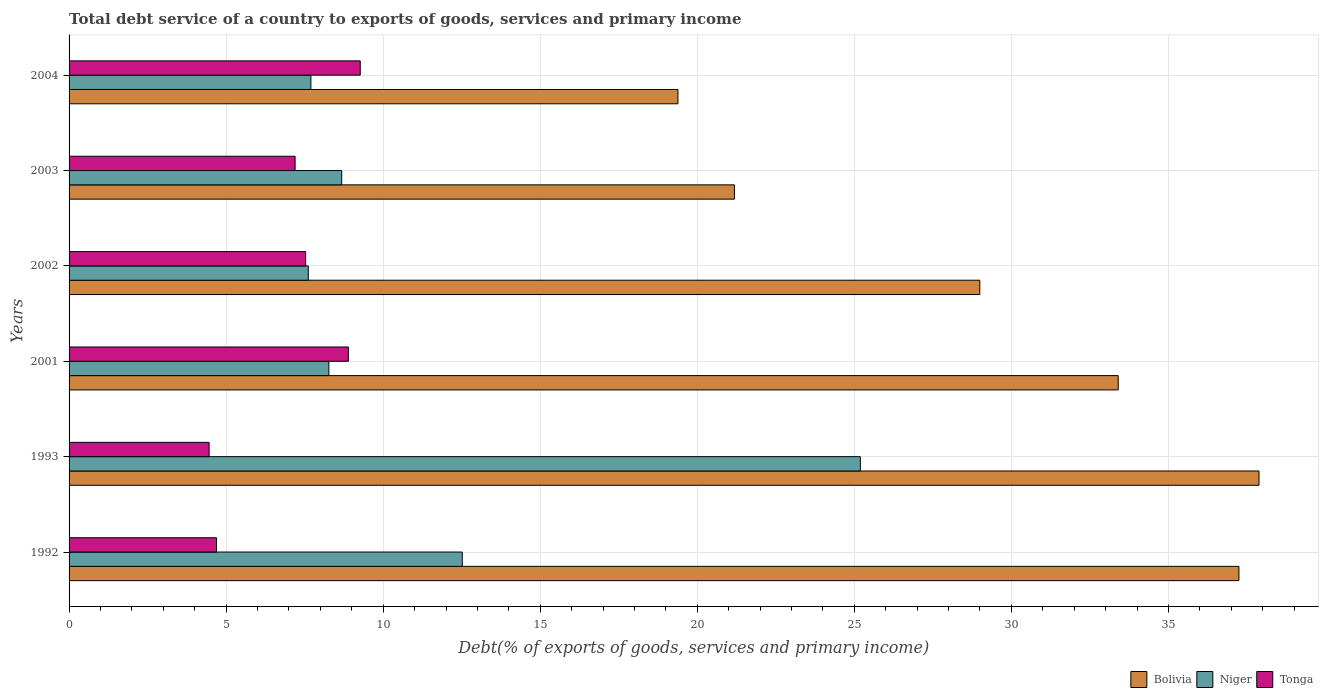Are the number of bars per tick equal to the number of legend labels?
Make the answer very short. Yes. Are the number of bars on each tick of the Y-axis equal?
Keep it short and to the point. Yes. How many bars are there on the 3rd tick from the bottom?
Offer a very short reply. 3. In how many cases, is the number of bars for a given year not equal to the number of legend labels?
Your answer should be very brief. 0. What is the total debt service in Tonga in 2003?
Ensure brevity in your answer.  7.2. Across all years, what is the maximum total debt service in Tonga?
Provide a succinct answer. 9.27. Across all years, what is the minimum total debt service in Tonga?
Give a very brief answer. 4.46. In which year was the total debt service in Tonga minimum?
Ensure brevity in your answer.  1993. What is the total total debt service in Tonga in the graph?
Make the answer very short. 42.04. What is the difference between the total debt service in Niger in 2002 and that in 2003?
Offer a very short reply. -1.06. What is the difference between the total debt service in Niger in 1993 and the total debt service in Tonga in 2003?
Your answer should be compact. 17.99. What is the average total debt service in Tonga per year?
Make the answer very short. 7.01. In the year 1992, what is the difference between the total debt service in Bolivia and total debt service in Niger?
Ensure brevity in your answer.  24.73. What is the ratio of the total debt service in Niger in 1993 to that in 2002?
Your response must be concise. 3.31. Is the total debt service in Niger in 1993 less than that in 2003?
Give a very brief answer. No. What is the difference between the highest and the second highest total debt service in Niger?
Keep it short and to the point. 12.67. What is the difference between the highest and the lowest total debt service in Tonga?
Ensure brevity in your answer.  4.81. In how many years, is the total debt service in Tonga greater than the average total debt service in Tonga taken over all years?
Provide a succinct answer. 4. Is the sum of the total debt service in Bolivia in 2001 and 2004 greater than the maximum total debt service in Tonga across all years?
Offer a terse response. Yes. What does the 2nd bar from the top in 2004 represents?
Offer a terse response. Niger. What does the 2nd bar from the bottom in 2001 represents?
Ensure brevity in your answer.  Niger. Is it the case that in every year, the sum of the total debt service in Tonga and total debt service in Bolivia is greater than the total debt service in Niger?
Your answer should be compact. Yes. Are all the bars in the graph horizontal?
Your answer should be compact. Yes. Does the graph contain any zero values?
Provide a succinct answer. No. How many legend labels are there?
Keep it short and to the point. 3. How are the legend labels stacked?
Provide a succinct answer. Horizontal. What is the title of the graph?
Your answer should be compact. Total debt service of a country to exports of goods, services and primary income. Does "Cote d'Ivoire" appear as one of the legend labels in the graph?
Ensure brevity in your answer.  No. What is the label or title of the X-axis?
Make the answer very short. Debt(% of exports of goods, services and primary income). What is the label or title of the Y-axis?
Provide a succinct answer. Years. What is the Debt(% of exports of goods, services and primary income) in Bolivia in 1992?
Make the answer very short. 37.24. What is the Debt(% of exports of goods, services and primary income) in Niger in 1992?
Your response must be concise. 12.52. What is the Debt(% of exports of goods, services and primary income) of Tonga in 1992?
Keep it short and to the point. 4.69. What is the Debt(% of exports of goods, services and primary income) in Bolivia in 1993?
Ensure brevity in your answer.  37.88. What is the Debt(% of exports of goods, services and primary income) in Niger in 1993?
Your answer should be compact. 25.19. What is the Debt(% of exports of goods, services and primary income) of Tonga in 1993?
Provide a short and direct response. 4.46. What is the Debt(% of exports of goods, services and primary income) in Bolivia in 2001?
Your response must be concise. 33.4. What is the Debt(% of exports of goods, services and primary income) of Niger in 2001?
Ensure brevity in your answer.  8.27. What is the Debt(% of exports of goods, services and primary income) in Tonga in 2001?
Your answer should be compact. 8.89. What is the Debt(% of exports of goods, services and primary income) in Bolivia in 2002?
Make the answer very short. 28.99. What is the Debt(% of exports of goods, services and primary income) of Niger in 2002?
Ensure brevity in your answer.  7.62. What is the Debt(% of exports of goods, services and primary income) of Tonga in 2002?
Offer a very short reply. 7.53. What is the Debt(% of exports of goods, services and primary income) in Bolivia in 2003?
Provide a succinct answer. 21.18. What is the Debt(% of exports of goods, services and primary income) in Niger in 2003?
Provide a short and direct response. 8.68. What is the Debt(% of exports of goods, services and primary income) in Tonga in 2003?
Keep it short and to the point. 7.2. What is the Debt(% of exports of goods, services and primary income) of Bolivia in 2004?
Provide a short and direct response. 19.38. What is the Debt(% of exports of goods, services and primary income) of Niger in 2004?
Keep it short and to the point. 7.7. What is the Debt(% of exports of goods, services and primary income) in Tonga in 2004?
Ensure brevity in your answer.  9.27. Across all years, what is the maximum Debt(% of exports of goods, services and primary income) of Bolivia?
Give a very brief answer. 37.88. Across all years, what is the maximum Debt(% of exports of goods, services and primary income) of Niger?
Give a very brief answer. 25.19. Across all years, what is the maximum Debt(% of exports of goods, services and primary income) of Tonga?
Provide a short and direct response. 9.27. Across all years, what is the minimum Debt(% of exports of goods, services and primary income) of Bolivia?
Offer a terse response. 19.38. Across all years, what is the minimum Debt(% of exports of goods, services and primary income) of Niger?
Offer a very short reply. 7.62. Across all years, what is the minimum Debt(% of exports of goods, services and primary income) in Tonga?
Offer a terse response. 4.46. What is the total Debt(% of exports of goods, services and primary income) in Bolivia in the graph?
Offer a terse response. 178.09. What is the total Debt(% of exports of goods, services and primary income) of Niger in the graph?
Ensure brevity in your answer.  69.97. What is the total Debt(% of exports of goods, services and primary income) of Tonga in the graph?
Offer a terse response. 42.04. What is the difference between the Debt(% of exports of goods, services and primary income) in Bolivia in 1992 and that in 1993?
Your response must be concise. -0.64. What is the difference between the Debt(% of exports of goods, services and primary income) of Niger in 1992 and that in 1993?
Ensure brevity in your answer.  -12.67. What is the difference between the Debt(% of exports of goods, services and primary income) of Tonga in 1992 and that in 1993?
Make the answer very short. 0.24. What is the difference between the Debt(% of exports of goods, services and primary income) of Bolivia in 1992 and that in 2001?
Give a very brief answer. 3.84. What is the difference between the Debt(% of exports of goods, services and primary income) of Niger in 1992 and that in 2001?
Your answer should be compact. 4.25. What is the difference between the Debt(% of exports of goods, services and primary income) in Tonga in 1992 and that in 2001?
Provide a short and direct response. -4.2. What is the difference between the Debt(% of exports of goods, services and primary income) of Bolivia in 1992 and that in 2002?
Give a very brief answer. 8.25. What is the difference between the Debt(% of exports of goods, services and primary income) of Niger in 1992 and that in 2002?
Your answer should be very brief. 4.9. What is the difference between the Debt(% of exports of goods, services and primary income) in Tonga in 1992 and that in 2002?
Keep it short and to the point. -2.84. What is the difference between the Debt(% of exports of goods, services and primary income) of Bolivia in 1992 and that in 2003?
Make the answer very short. 16.06. What is the difference between the Debt(% of exports of goods, services and primary income) in Niger in 1992 and that in 2003?
Offer a very short reply. 3.84. What is the difference between the Debt(% of exports of goods, services and primary income) of Tonga in 1992 and that in 2003?
Your answer should be very brief. -2.5. What is the difference between the Debt(% of exports of goods, services and primary income) of Bolivia in 1992 and that in 2004?
Give a very brief answer. 17.86. What is the difference between the Debt(% of exports of goods, services and primary income) in Niger in 1992 and that in 2004?
Offer a terse response. 4.82. What is the difference between the Debt(% of exports of goods, services and primary income) in Tonga in 1992 and that in 2004?
Offer a very short reply. -4.58. What is the difference between the Debt(% of exports of goods, services and primary income) in Bolivia in 1993 and that in 2001?
Offer a terse response. 4.48. What is the difference between the Debt(% of exports of goods, services and primary income) in Niger in 1993 and that in 2001?
Offer a very short reply. 16.92. What is the difference between the Debt(% of exports of goods, services and primary income) in Tonga in 1993 and that in 2001?
Provide a succinct answer. -4.43. What is the difference between the Debt(% of exports of goods, services and primary income) in Bolivia in 1993 and that in 2002?
Give a very brief answer. 8.89. What is the difference between the Debt(% of exports of goods, services and primary income) in Niger in 1993 and that in 2002?
Your response must be concise. 17.58. What is the difference between the Debt(% of exports of goods, services and primary income) in Tonga in 1993 and that in 2002?
Keep it short and to the point. -3.07. What is the difference between the Debt(% of exports of goods, services and primary income) of Bolivia in 1993 and that in 2003?
Give a very brief answer. 16.7. What is the difference between the Debt(% of exports of goods, services and primary income) of Niger in 1993 and that in 2003?
Offer a very short reply. 16.51. What is the difference between the Debt(% of exports of goods, services and primary income) of Tonga in 1993 and that in 2003?
Ensure brevity in your answer.  -2.74. What is the difference between the Debt(% of exports of goods, services and primary income) in Bolivia in 1993 and that in 2004?
Give a very brief answer. 18.5. What is the difference between the Debt(% of exports of goods, services and primary income) in Niger in 1993 and that in 2004?
Your answer should be very brief. 17.49. What is the difference between the Debt(% of exports of goods, services and primary income) of Tonga in 1993 and that in 2004?
Provide a succinct answer. -4.81. What is the difference between the Debt(% of exports of goods, services and primary income) in Bolivia in 2001 and that in 2002?
Your response must be concise. 4.41. What is the difference between the Debt(% of exports of goods, services and primary income) of Niger in 2001 and that in 2002?
Provide a succinct answer. 0.66. What is the difference between the Debt(% of exports of goods, services and primary income) of Tonga in 2001 and that in 2002?
Your response must be concise. 1.36. What is the difference between the Debt(% of exports of goods, services and primary income) of Bolivia in 2001 and that in 2003?
Ensure brevity in your answer.  12.22. What is the difference between the Debt(% of exports of goods, services and primary income) in Niger in 2001 and that in 2003?
Your answer should be very brief. -0.41. What is the difference between the Debt(% of exports of goods, services and primary income) in Tonga in 2001 and that in 2003?
Provide a succinct answer. 1.7. What is the difference between the Debt(% of exports of goods, services and primary income) of Bolivia in 2001 and that in 2004?
Provide a short and direct response. 14.02. What is the difference between the Debt(% of exports of goods, services and primary income) in Niger in 2001 and that in 2004?
Give a very brief answer. 0.57. What is the difference between the Debt(% of exports of goods, services and primary income) of Tonga in 2001 and that in 2004?
Your answer should be very brief. -0.38. What is the difference between the Debt(% of exports of goods, services and primary income) in Bolivia in 2002 and that in 2003?
Offer a very short reply. 7.81. What is the difference between the Debt(% of exports of goods, services and primary income) in Niger in 2002 and that in 2003?
Give a very brief answer. -1.06. What is the difference between the Debt(% of exports of goods, services and primary income) of Tonga in 2002 and that in 2003?
Your response must be concise. 0.33. What is the difference between the Debt(% of exports of goods, services and primary income) of Bolivia in 2002 and that in 2004?
Offer a terse response. 9.61. What is the difference between the Debt(% of exports of goods, services and primary income) of Niger in 2002 and that in 2004?
Keep it short and to the point. -0.08. What is the difference between the Debt(% of exports of goods, services and primary income) of Tonga in 2002 and that in 2004?
Your answer should be compact. -1.74. What is the difference between the Debt(% of exports of goods, services and primary income) of Bolivia in 2003 and that in 2004?
Give a very brief answer. 1.8. What is the difference between the Debt(% of exports of goods, services and primary income) in Niger in 2003 and that in 2004?
Provide a short and direct response. 0.98. What is the difference between the Debt(% of exports of goods, services and primary income) in Tonga in 2003 and that in 2004?
Provide a succinct answer. -2.07. What is the difference between the Debt(% of exports of goods, services and primary income) in Bolivia in 1992 and the Debt(% of exports of goods, services and primary income) in Niger in 1993?
Provide a succinct answer. 12.05. What is the difference between the Debt(% of exports of goods, services and primary income) of Bolivia in 1992 and the Debt(% of exports of goods, services and primary income) of Tonga in 1993?
Your response must be concise. 32.79. What is the difference between the Debt(% of exports of goods, services and primary income) in Niger in 1992 and the Debt(% of exports of goods, services and primary income) in Tonga in 1993?
Offer a very short reply. 8.06. What is the difference between the Debt(% of exports of goods, services and primary income) of Bolivia in 1992 and the Debt(% of exports of goods, services and primary income) of Niger in 2001?
Keep it short and to the point. 28.97. What is the difference between the Debt(% of exports of goods, services and primary income) of Bolivia in 1992 and the Debt(% of exports of goods, services and primary income) of Tonga in 2001?
Your answer should be very brief. 28.35. What is the difference between the Debt(% of exports of goods, services and primary income) in Niger in 1992 and the Debt(% of exports of goods, services and primary income) in Tonga in 2001?
Provide a short and direct response. 3.63. What is the difference between the Debt(% of exports of goods, services and primary income) of Bolivia in 1992 and the Debt(% of exports of goods, services and primary income) of Niger in 2002?
Offer a terse response. 29.63. What is the difference between the Debt(% of exports of goods, services and primary income) of Bolivia in 1992 and the Debt(% of exports of goods, services and primary income) of Tonga in 2002?
Your response must be concise. 29.71. What is the difference between the Debt(% of exports of goods, services and primary income) in Niger in 1992 and the Debt(% of exports of goods, services and primary income) in Tonga in 2002?
Offer a very short reply. 4.99. What is the difference between the Debt(% of exports of goods, services and primary income) in Bolivia in 1992 and the Debt(% of exports of goods, services and primary income) in Niger in 2003?
Provide a short and direct response. 28.57. What is the difference between the Debt(% of exports of goods, services and primary income) in Bolivia in 1992 and the Debt(% of exports of goods, services and primary income) in Tonga in 2003?
Keep it short and to the point. 30.05. What is the difference between the Debt(% of exports of goods, services and primary income) of Niger in 1992 and the Debt(% of exports of goods, services and primary income) of Tonga in 2003?
Make the answer very short. 5.32. What is the difference between the Debt(% of exports of goods, services and primary income) of Bolivia in 1992 and the Debt(% of exports of goods, services and primary income) of Niger in 2004?
Ensure brevity in your answer.  29.55. What is the difference between the Debt(% of exports of goods, services and primary income) in Bolivia in 1992 and the Debt(% of exports of goods, services and primary income) in Tonga in 2004?
Offer a terse response. 27.97. What is the difference between the Debt(% of exports of goods, services and primary income) of Niger in 1992 and the Debt(% of exports of goods, services and primary income) of Tonga in 2004?
Offer a very short reply. 3.25. What is the difference between the Debt(% of exports of goods, services and primary income) in Bolivia in 1993 and the Debt(% of exports of goods, services and primary income) in Niger in 2001?
Offer a terse response. 29.61. What is the difference between the Debt(% of exports of goods, services and primary income) of Bolivia in 1993 and the Debt(% of exports of goods, services and primary income) of Tonga in 2001?
Your answer should be very brief. 28.99. What is the difference between the Debt(% of exports of goods, services and primary income) of Niger in 1993 and the Debt(% of exports of goods, services and primary income) of Tonga in 2001?
Provide a short and direct response. 16.3. What is the difference between the Debt(% of exports of goods, services and primary income) of Bolivia in 1993 and the Debt(% of exports of goods, services and primary income) of Niger in 2002?
Make the answer very short. 30.27. What is the difference between the Debt(% of exports of goods, services and primary income) in Bolivia in 1993 and the Debt(% of exports of goods, services and primary income) in Tonga in 2002?
Ensure brevity in your answer.  30.35. What is the difference between the Debt(% of exports of goods, services and primary income) of Niger in 1993 and the Debt(% of exports of goods, services and primary income) of Tonga in 2002?
Make the answer very short. 17.66. What is the difference between the Debt(% of exports of goods, services and primary income) of Bolivia in 1993 and the Debt(% of exports of goods, services and primary income) of Niger in 2003?
Make the answer very short. 29.2. What is the difference between the Debt(% of exports of goods, services and primary income) in Bolivia in 1993 and the Debt(% of exports of goods, services and primary income) in Tonga in 2003?
Make the answer very short. 30.69. What is the difference between the Debt(% of exports of goods, services and primary income) in Niger in 1993 and the Debt(% of exports of goods, services and primary income) in Tonga in 2003?
Make the answer very short. 17.99. What is the difference between the Debt(% of exports of goods, services and primary income) of Bolivia in 1993 and the Debt(% of exports of goods, services and primary income) of Niger in 2004?
Provide a succinct answer. 30.18. What is the difference between the Debt(% of exports of goods, services and primary income) of Bolivia in 1993 and the Debt(% of exports of goods, services and primary income) of Tonga in 2004?
Provide a succinct answer. 28.61. What is the difference between the Debt(% of exports of goods, services and primary income) in Niger in 1993 and the Debt(% of exports of goods, services and primary income) in Tonga in 2004?
Give a very brief answer. 15.92. What is the difference between the Debt(% of exports of goods, services and primary income) of Bolivia in 2001 and the Debt(% of exports of goods, services and primary income) of Niger in 2002?
Give a very brief answer. 25.79. What is the difference between the Debt(% of exports of goods, services and primary income) of Bolivia in 2001 and the Debt(% of exports of goods, services and primary income) of Tonga in 2002?
Your answer should be compact. 25.87. What is the difference between the Debt(% of exports of goods, services and primary income) in Niger in 2001 and the Debt(% of exports of goods, services and primary income) in Tonga in 2002?
Offer a very short reply. 0.74. What is the difference between the Debt(% of exports of goods, services and primary income) in Bolivia in 2001 and the Debt(% of exports of goods, services and primary income) in Niger in 2003?
Give a very brief answer. 24.72. What is the difference between the Debt(% of exports of goods, services and primary income) in Bolivia in 2001 and the Debt(% of exports of goods, services and primary income) in Tonga in 2003?
Offer a terse response. 26.21. What is the difference between the Debt(% of exports of goods, services and primary income) of Niger in 2001 and the Debt(% of exports of goods, services and primary income) of Tonga in 2003?
Your answer should be very brief. 1.07. What is the difference between the Debt(% of exports of goods, services and primary income) in Bolivia in 2001 and the Debt(% of exports of goods, services and primary income) in Niger in 2004?
Ensure brevity in your answer.  25.7. What is the difference between the Debt(% of exports of goods, services and primary income) of Bolivia in 2001 and the Debt(% of exports of goods, services and primary income) of Tonga in 2004?
Your answer should be compact. 24.13. What is the difference between the Debt(% of exports of goods, services and primary income) of Niger in 2001 and the Debt(% of exports of goods, services and primary income) of Tonga in 2004?
Your answer should be very brief. -1. What is the difference between the Debt(% of exports of goods, services and primary income) of Bolivia in 2002 and the Debt(% of exports of goods, services and primary income) of Niger in 2003?
Ensure brevity in your answer.  20.32. What is the difference between the Debt(% of exports of goods, services and primary income) in Bolivia in 2002 and the Debt(% of exports of goods, services and primary income) in Tonga in 2003?
Make the answer very short. 21.8. What is the difference between the Debt(% of exports of goods, services and primary income) of Niger in 2002 and the Debt(% of exports of goods, services and primary income) of Tonga in 2003?
Keep it short and to the point. 0.42. What is the difference between the Debt(% of exports of goods, services and primary income) in Bolivia in 2002 and the Debt(% of exports of goods, services and primary income) in Niger in 2004?
Your answer should be compact. 21.3. What is the difference between the Debt(% of exports of goods, services and primary income) in Bolivia in 2002 and the Debt(% of exports of goods, services and primary income) in Tonga in 2004?
Provide a short and direct response. 19.72. What is the difference between the Debt(% of exports of goods, services and primary income) of Niger in 2002 and the Debt(% of exports of goods, services and primary income) of Tonga in 2004?
Ensure brevity in your answer.  -1.65. What is the difference between the Debt(% of exports of goods, services and primary income) in Bolivia in 2003 and the Debt(% of exports of goods, services and primary income) in Niger in 2004?
Your answer should be very brief. 13.48. What is the difference between the Debt(% of exports of goods, services and primary income) of Bolivia in 2003 and the Debt(% of exports of goods, services and primary income) of Tonga in 2004?
Offer a terse response. 11.91. What is the difference between the Debt(% of exports of goods, services and primary income) in Niger in 2003 and the Debt(% of exports of goods, services and primary income) in Tonga in 2004?
Offer a terse response. -0.59. What is the average Debt(% of exports of goods, services and primary income) of Bolivia per year?
Your response must be concise. 29.68. What is the average Debt(% of exports of goods, services and primary income) in Niger per year?
Provide a short and direct response. 11.66. What is the average Debt(% of exports of goods, services and primary income) of Tonga per year?
Provide a short and direct response. 7.01. In the year 1992, what is the difference between the Debt(% of exports of goods, services and primary income) in Bolivia and Debt(% of exports of goods, services and primary income) in Niger?
Make the answer very short. 24.73. In the year 1992, what is the difference between the Debt(% of exports of goods, services and primary income) in Bolivia and Debt(% of exports of goods, services and primary income) in Tonga?
Your answer should be very brief. 32.55. In the year 1992, what is the difference between the Debt(% of exports of goods, services and primary income) in Niger and Debt(% of exports of goods, services and primary income) in Tonga?
Offer a terse response. 7.83. In the year 1993, what is the difference between the Debt(% of exports of goods, services and primary income) in Bolivia and Debt(% of exports of goods, services and primary income) in Niger?
Provide a short and direct response. 12.69. In the year 1993, what is the difference between the Debt(% of exports of goods, services and primary income) in Bolivia and Debt(% of exports of goods, services and primary income) in Tonga?
Your answer should be very brief. 33.42. In the year 1993, what is the difference between the Debt(% of exports of goods, services and primary income) of Niger and Debt(% of exports of goods, services and primary income) of Tonga?
Keep it short and to the point. 20.73. In the year 2001, what is the difference between the Debt(% of exports of goods, services and primary income) of Bolivia and Debt(% of exports of goods, services and primary income) of Niger?
Your response must be concise. 25.13. In the year 2001, what is the difference between the Debt(% of exports of goods, services and primary income) in Bolivia and Debt(% of exports of goods, services and primary income) in Tonga?
Ensure brevity in your answer.  24.51. In the year 2001, what is the difference between the Debt(% of exports of goods, services and primary income) in Niger and Debt(% of exports of goods, services and primary income) in Tonga?
Your answer should be very brief. -0.62. In the year 2002, what is the difference between the Debt(% of exports of goods, services and primary income) of Bolivia and Debt(% of exports of goods, services and primary income) of Niger?
Your answer should be very brief. 21.38. In the year 2002, what is the difference between the Debt(% of exports of goods, services and primary income) of Bolivia and Debt(% of exports of goods, services and primary income) of Tonga?
Provide a short and direct response. 21.46. In the year 2002, what is the difference between the Debt(% of exports of goods, services and primary income) in Niger and Debt(% of exports of goods, services and primary income) in Tonga?
Your answer should be very brief. 0.08. In the year 2003, what is the difference between the Debt(% of exports of goods, services and primary income) of Bolivia and Debt(% of exports of goods, services and primary income) of Niger?
Your response must be concise. 12.5. In the year 2003, what is the difference between the Debt(% of exports of goods, services and primary income) in Bolivia and Debt(% of exports of goods, services and primary income) in Tonga?
Make the answer very short. 13.99. In the year 2003, what is the difference between the Debt(% of exports of goods, services and primary income) of Niger and Debt(% of exports of goods, services and primary income) of Tonga?
Provide a short and direct response. 1.48. In the year 2004, what is the difference between the Debt(% of exports of goods, services and primary income) in Bolivia and Debt(% of exports of goods, services and primary income) in Niger?
Keep it short and to the point. 11.69. In the year 2004, what is the difference between the Debt(% of exports of goods, services and primary income) in Bolivia and Debt(% of exports of goods, services and primary income) in Tonga?
Keep it short and to the point. 10.11. In the year 2004, what is the difference between the Debt(% of exports of goods, services and primary income) in Niger and Debt(% of exports of goods, services and primary income) in Tonga?
Your response must be concise. -1.57. What is the ratio of the Debt(% of exports of goods, services and primary income) in Bolivia in 1992 to that in 1993?
Your response must be concise. 0.98. What is the ratio of the Debt(% of exports of goods, services and primary income) in Niger in 1992 to that in 1993?
Make the answer very short. 0.5. What is the ratio of the Debt(% of exports of goods, services and primary income) in Tonga in 1992 to that in 1993?
Provide a short and direct response. 1.05. What is the ratio of the Debt(% of exports of goods, services and primary income) in Bolivia in 1992 to that in 2001?
Give a very brief answer. 1.12. What is the ratio of the Debt(% of exports of goods, services and primary income) of Niger in 1992 to that in 2001?
Your answer should be compact. 1.51. What is the ratio of the Debt(% of exports of goods, services and primary income) of Tonga in 1992 to that in 2001?
Provide a succinct answer. 0.53. What is the ratio of the Debt(% of exports of goods, services and primary income) of Bolivia in 1992 to that in 2002?
Give a very brief answer. 1.28. What is the ratio of the Debt(% of exports of goods, services and primary income) of Niger in 1992 to that in 2002?
Keep it short and to the point. 1.64. What is the ratio of the Debt(% of exports of goods, services and primary income) of Tonga in 1992 to that in 2002?
Offer a terse response. 0.62. What is the ratio of the Debt(% of exports of goods, services and primary income) in Bolivia in 1992 to that in 2003?
Provide a succinct answer. 1.76. What is the ratio of the Debt(% of exports of goods, services and primary income) in Niger in 1992 to that in 2003?
Ensure brevity in your answer.  1.44. What is the ratio of the Debt(% of exports of goods, services and primary income) in Tonga in 1992 to that in 2003?
Keep it short and to the point. 0.65. What is the ratio of the Debt(% of exports of goods, services and primary income) in Bolivia in 1992 to that in 2004?
Offer a very short reply. 1.92. What is the ratio of the Debt(% of exports of goods, services and primary income) in Niger in 1992 to that in 2004?
Give a very brief answer. 1.63. What is the ratio of the Debt(% of exports of goods, services and primary income) in Tonga in 1992 to that in 2004?
Give a very brief answer. 0.51. What is the ratio of the Debt(% of exports of goods, services and primary income) in Bolivia in 1993 to that in 2001?
Your response must be concise. 1.13. What is the ratio of the Debt(% of exports of goods, services and primary income) in Niger in 1993 to that in 2001?
Ensure brevity in your answer.  3.05. What is the ratio of the Debt(% of exports of goods, services and primary income) in Tonga in 1993 to that in 2001?
Offer a very short reply. 0.5. What is the ratio of the Debt(% of exports of goods, services and primary income) of Bolivia in 1993 to that in 2002?
Your answer should be compact. 1.31. What is the ratio of the Debt(% of exports of goods, services and primary income) in Niger in 1993 to that in 2002?
Make the answer very short. 3.31. What is the ratio of the Debt(% of exports of goods, services and primary income) of Tonga in 1993 to that in 2002?
Offer a very short reply. 0.59. What is the ratio of the Debt(% of exports of goods, services and primary income) of Bolivia in 1993 to that in 2003?
Give a very brief answer. 1.79. What is the ratio of the Debt(% of exports of goods, services and primary income) of Niger in 1993 to that in 2003?
Make the answer very short. 2.9. What is the ratio of the Debt(% of exports of goods, services and primary income) of Tonga in 1993 to that in 2003?
Offer a terse response. 0.62. What is the ratio of the Debt(% of exports of goods, services and primary income) of Bolivia in 1993 to that in 2004?
Make the answer very short. 1.95. What is the ratio of the Debt(% of exports of goods, services and primary income) in Niger in 1993 to that in 2004?
Your response must be concise. 3.27. What is the ratio of the Debt(% of exports of goods, services and primary income) of Tonga in 1993 to that in 2004?
Offer a terse response. 0.48. What is the ratio of the Debt(% of exports of goods, services and primary income) of Bolivia in 2001 to that in 2002?
Your answer should be compact. 1.15. What is the ratio of the Debt(% of exports of goods, services and primary income) in Niger in 2001 to that in 2002?
Make the answer very short. 1.09. What is the ratio of the Debt(% of exports of goods, services and primary income) of Tonga in 2001 to that in 2002?
Give a very brief answer. 1.18. What is the ratio of the Debt(% of exports of goods, services and primary income) in Bolivia in 2001 to that in 2003?
Your answer should be compact. 1.58. What is the ratio of the Debt(% of exports of goods, services and primary income) in Niger in 2001 to that in 2003?
Offer a terse response. 0.95. What is the ratio of the Debt(% of exports of goods, services and primary income) in Tonga in 2001 to that in 2003?
Give a very brief answer. 1.24. What is the ratio of the Debt(% of exports of goods, services and primary income) in Bolivia in 2001 to that in 2004?
Give a very brief answer. 1.72. What is the ratio of the Debt(% of exports of goods, services and primary income) in Niger in 2001 to that in 2004?
Your answer should be compact. 1.07. What is the ratio of the Debt(% of exports of goods, services and primary income) in Tonga in 2001 to that in 2004?
Give a very brief answer. 0.96. What is the ratio of the Debt(% of exports of goods, services and primary income) in Bolivia in 2002 to that in 2003?
Your answer should be compact. 1.37. What is the ratio of the Debt(% of exports of goods, services and primary income) in Niger in 2002 to that in 2003?
Provide a succinct answer. 0.88. What is the ratio of the Debt(% of exports of goods, services and primary income) in Tonga in 2002 to that in 2003?
Offer a very short reply. 1.05. What is the ratio of the Debt(% of exports of goods, services and primary income) in Bolivia in 2002 to that in 2004?
Give a very brief answer. 1.5. What is the ratio of the Debt(% of exports of goods, services and primary income) in Niger in 2002 to that in 2004?
Offer a very short reply. 0.99. What is the ratio of the Debt(% of exports of goods, services and primary income) of Tonga in 2002 to that in 2004?
Provide a succinct answer. 0.81. What is the ratio of the Debt(% of exports of goods, services and primary income) in Bolivia in 2003 to that in 2004?
Provide a short and direct response. 1.09. What is the ratio of the Debt(% of exports of goods, services and primary income) of Niger in 2003 to that in 2004?
Offer a very short reply. 1.13. What is the ratio of the Debt(% of exports of goods, services and primary income) in Tonga in 2003 to that in 2004?
Your response must be concise. 0.78. What is the difference between the highest and the second highest Debt(% of exports of goods, services and primary income) of Bolivia?
Your response must be concise. 0.64. What is the difference between the highest and the second highest Debt(% of exports of goods, services and primary income) of Niger?
Offer a very short reply. 12.67. What is the difference between the highest and the second highest Debt(% of exports of goods, services and primary income) in Tonga?
Your response must be concise. 0.38. What is the difference between the highest and the lowest Debt(% of exports of goods, services and primary income) in Bolivia?
Your answer should be compact. 18.5. What is the difference between the highest and the lowest Debt(% of exports of goods, services and primary income) in Niger?
Ensure brevity in your answer.  17.58. What is the difference between the highest and the lowest Debt(% of exports of goods, services and primary income) in Tonga?
Keep it short and to the point. 4.81. 